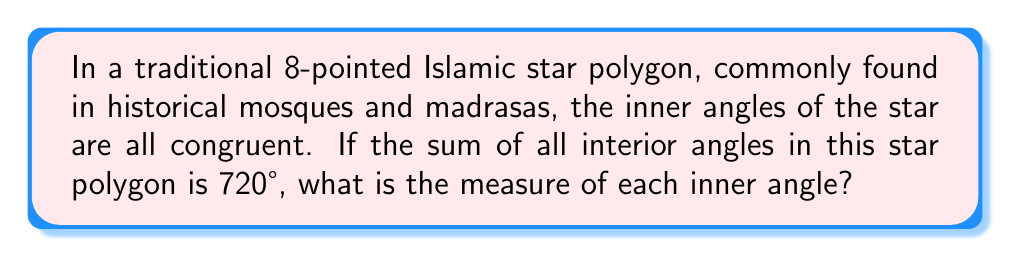Can you answer this question? Let's approach this step-by-step:

1) First, recall that in a regular star polygon, all inner angles are congruent.

2) We're given that the sum of all interior angles is 720°.

3) The star has 8 points, so there are 8 inner angles.

4) Let's denote the measure of each inner angle as $x$.

5) Since there are 8 angles and their sum is 720°, we can set up the equation:

   $$8x = 720°$$

6) To solve for $x$, we divide both sides by 8:

   $$x = \frac{720°}{8} = 90°$$

7) Therefore, each inner angle of the 8-pointed Islamic star polygon measures 90°.

This result is significant in Islamic geometric patterns, as the 90° angle allows for easy tessellation and integration with other geometric shapes in complex designs.
Answer: $90°$ 